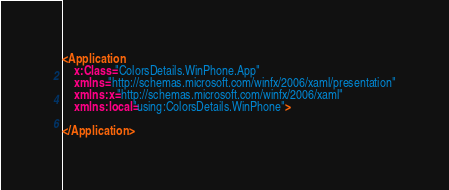<code> <loc_0><loc_0><loc_500><loc_500><_XML_><Application
    x:Class="ColorsDetails.WinPhone.App"
    xmlns="http://schemas.microsoft.com/winfx/2006/xaml/presentation"
    xmlns:x="http://schemas.microsoft.com/winfx/2006/xaml"
    xmlns:local="using:ColorsDetails.WinPhone">

</Application></code> 